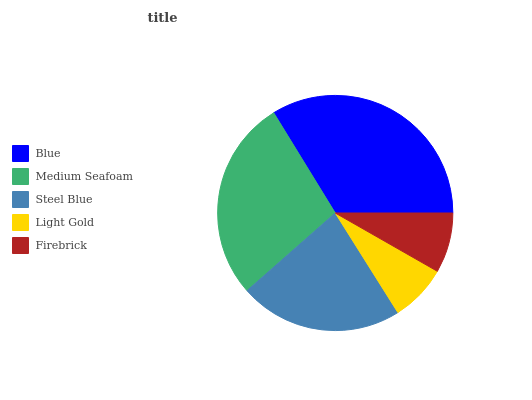Is Light Gold the minimum?
Answer yes or no. Yes. Is Blue the maximum?
Answer yes or no. Yes. Is Medium Seafoam the minimum?
Answer yes or no. No. Is Medium Seafoam the maximum?
Answer yes or no. No. Is Blue greater than Medium Seafoam?
Answer yes or no. Yes. Is Medium Seafoam less than Blue?
Answer yes or no. Yes. Is Medium Seafoam greater than Blue?
Answer yes or no. No. Is Blue less than Medium Seafoam?
Answer yes or no. No. Is Steel Blue the high median?
Answer yes or no. Yes. Is Steel Blue the low median?
Answer yes or no. Yes. Is Medium Seafoam the high median?
Answer yes or no. No. Is Medium Seafoam the low median?
Answer yes or no. No. 